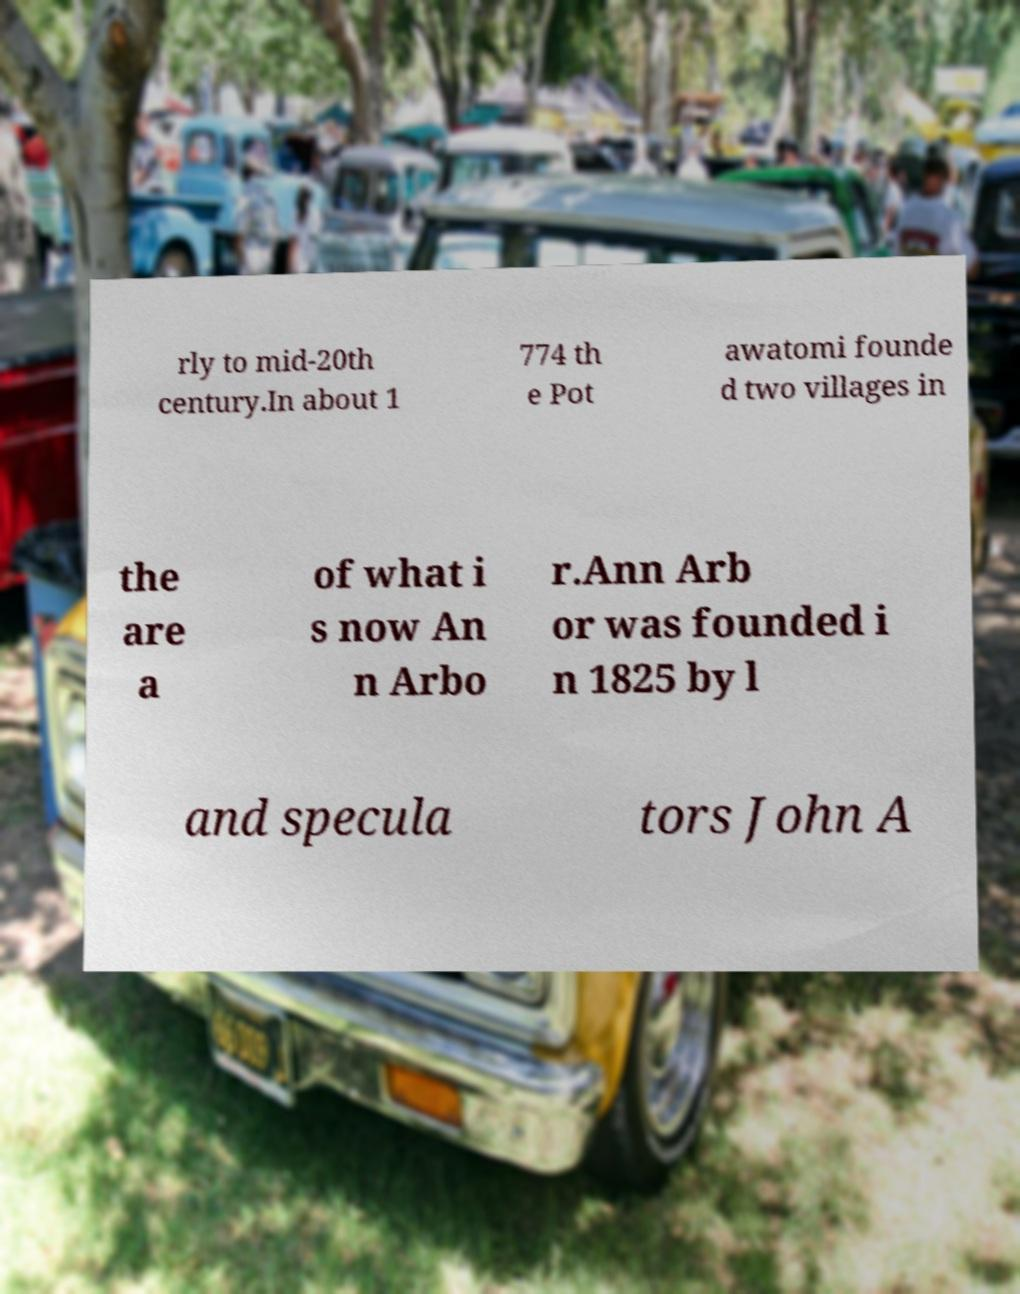There's text embedded in this image that I need extracted. Can you transcribe it verbatim? rly to mid-20th century.In about 1 774 th e Pot awatomi founde d two villages in the are a of what i s now An n Arbo r.Ann Arb or was founded i n 1825 by l and specula tors John A 